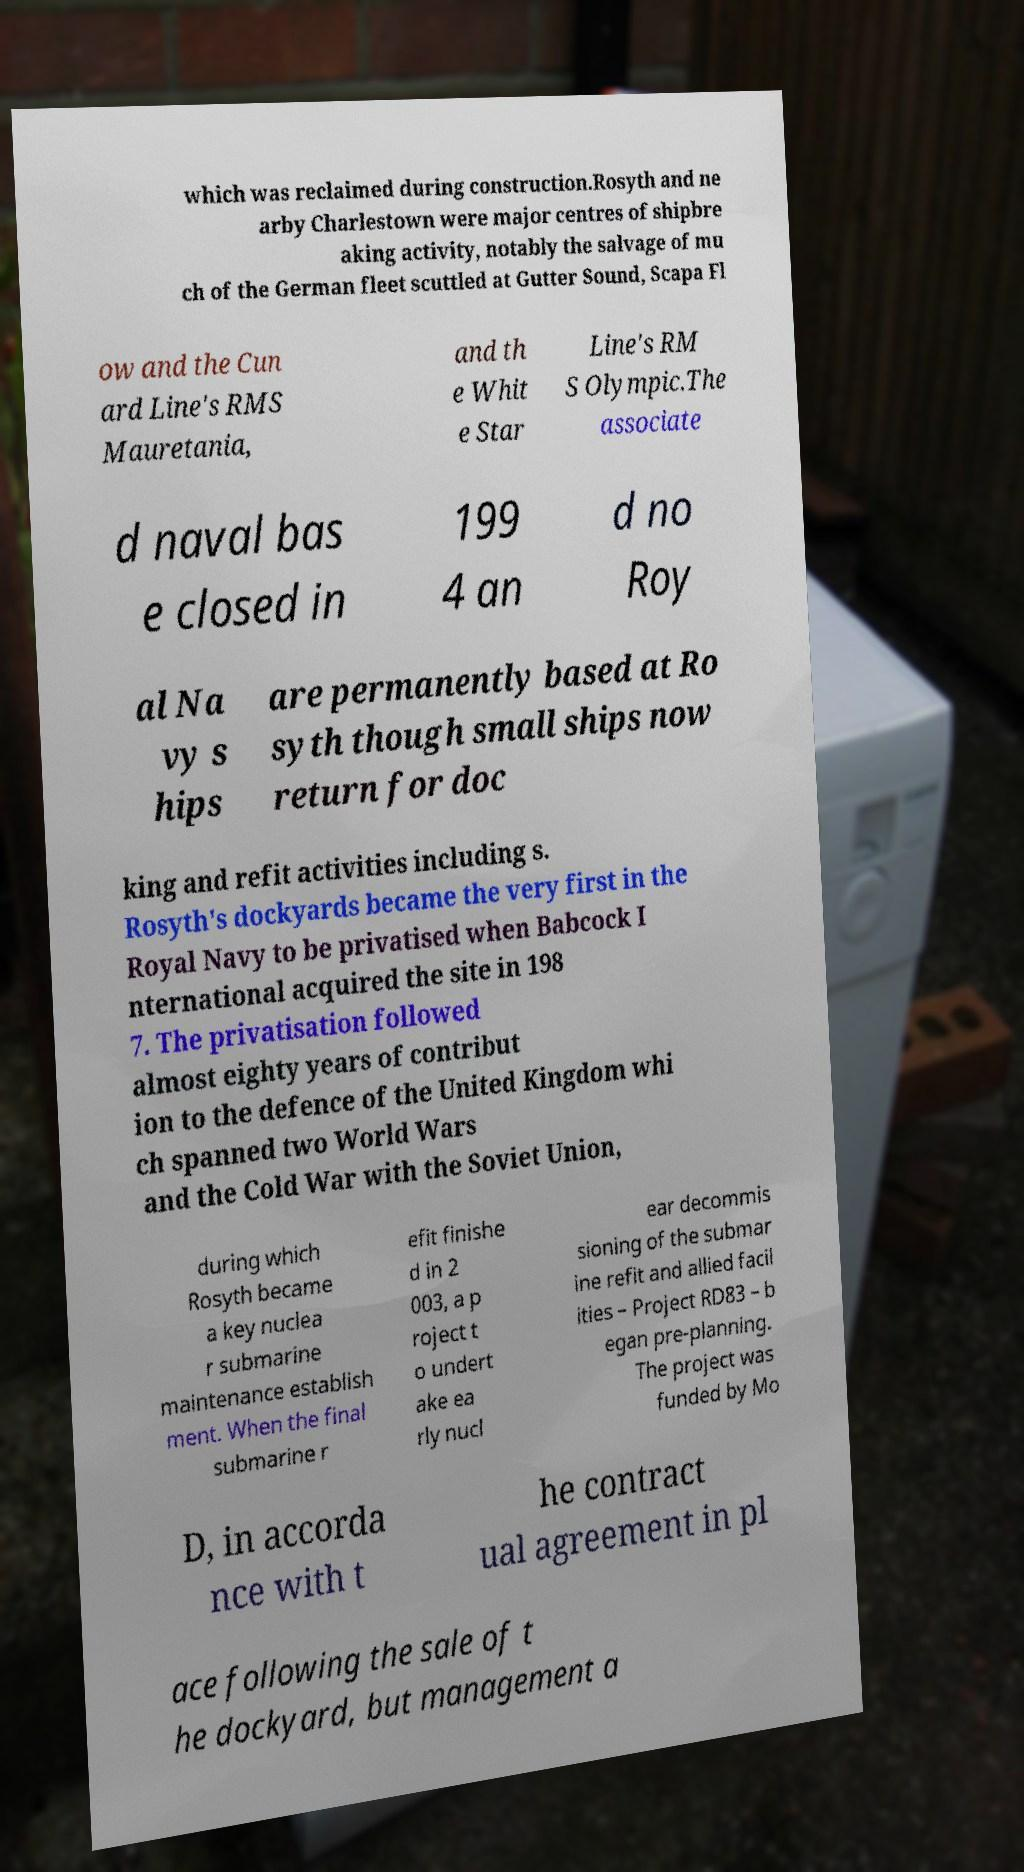Can you accurately transcribe the text from the provided image for me? which was reclaimed during construction.Rosyth and ne arby Charlestown were major centres of shipbre aking activity, notably the salvage of mu ch of the German fleet scuttled at Gutter Sound, Scapa Fl ow and the Cun ard Line's RMS Mauretania, and th e Whit e Star Line's RM S Olympic.The associate d naval bas e closed in 199 4 an d no Roy al Na vy s hips are permanently based at Ro syth though small ships now return for doc king and refit activities including s. Rosyth's dockyards became the very first in the Royal Navy to be privatised when Babcock I nternational acquired the site in 198 7. The privatisation followed almost eighty years of contribut ion to the defence of the United Kingdom whi ch spanned two World Wars and the Cold War with the Soviet Union, during which Rosyth became a key nuclea r submarine maintenance establish ment. When the final submarine r efit finishe d in 2 003, a p roject t o undert ake ea rly nucl ear decommis sioning of the submar ine refit and allied facil ities – Project RD83 – b egan pre-planning. The project was funded by Mo D, in accorda nce with t he contract ual agreement in pl ace following the sale of t he dockyard, but management a 